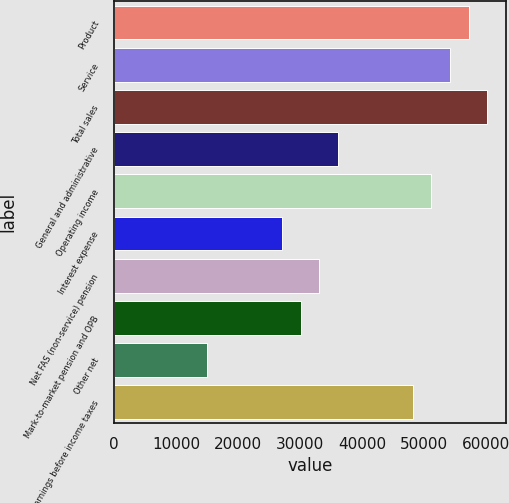<chart> <loc_0><loc_0><loc_500><loc_500><bar_chart><fcel>Product<fcel>Service<fcel>Total sales<fcel>General and administrative<fcel>Operating income<fcel>Interest expense<fcel>Net FAS (non-service) pension<fcel>Mark-to-market pension and OPB<fcel>Other net<fcel>Earnings before income taxes<nl><fcel>57173.3<fcel>54164.6<fcel>60182<fcel>36112.4<fcel>51155.9<fcel>27086.3<fcel>33103.7<fcel>30095<fcel>15051.5<fcel>48147.2<nl></chart> 